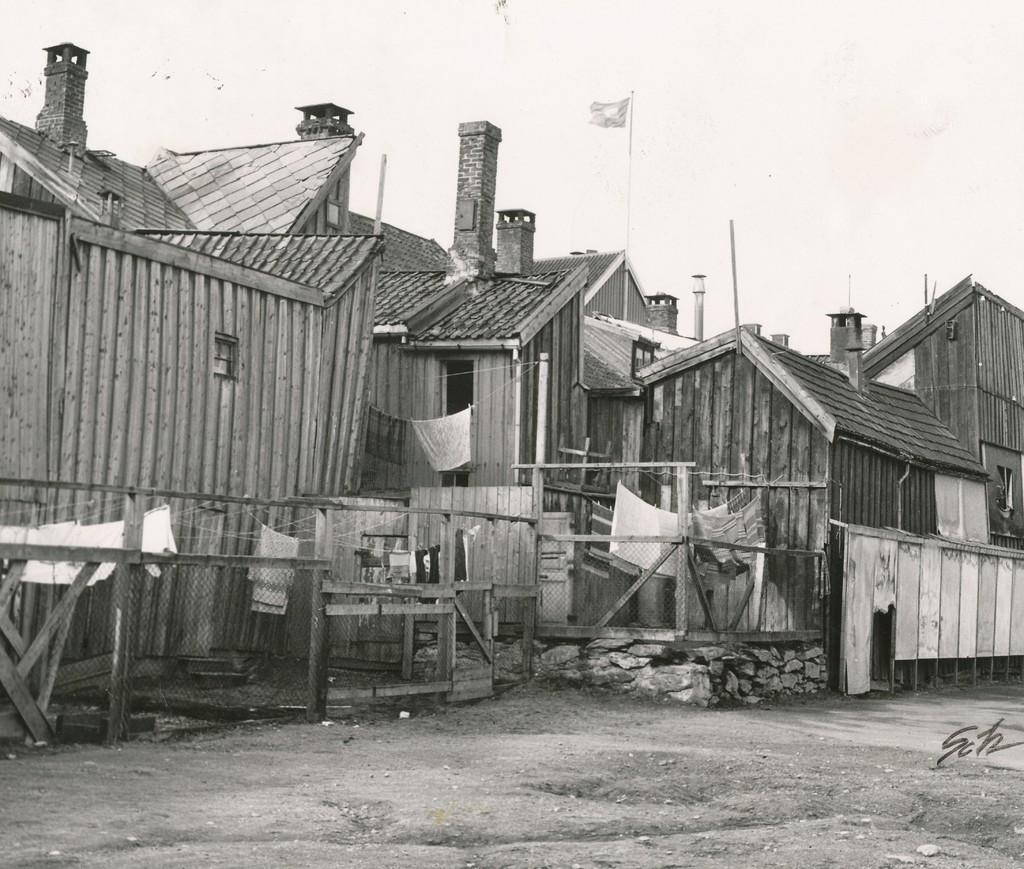In one or two sentences, can you explain what this image depicts? This picture shows few wooden houses and we see a flag pole and few clothes on the ropes and we see a cloudy sky. 